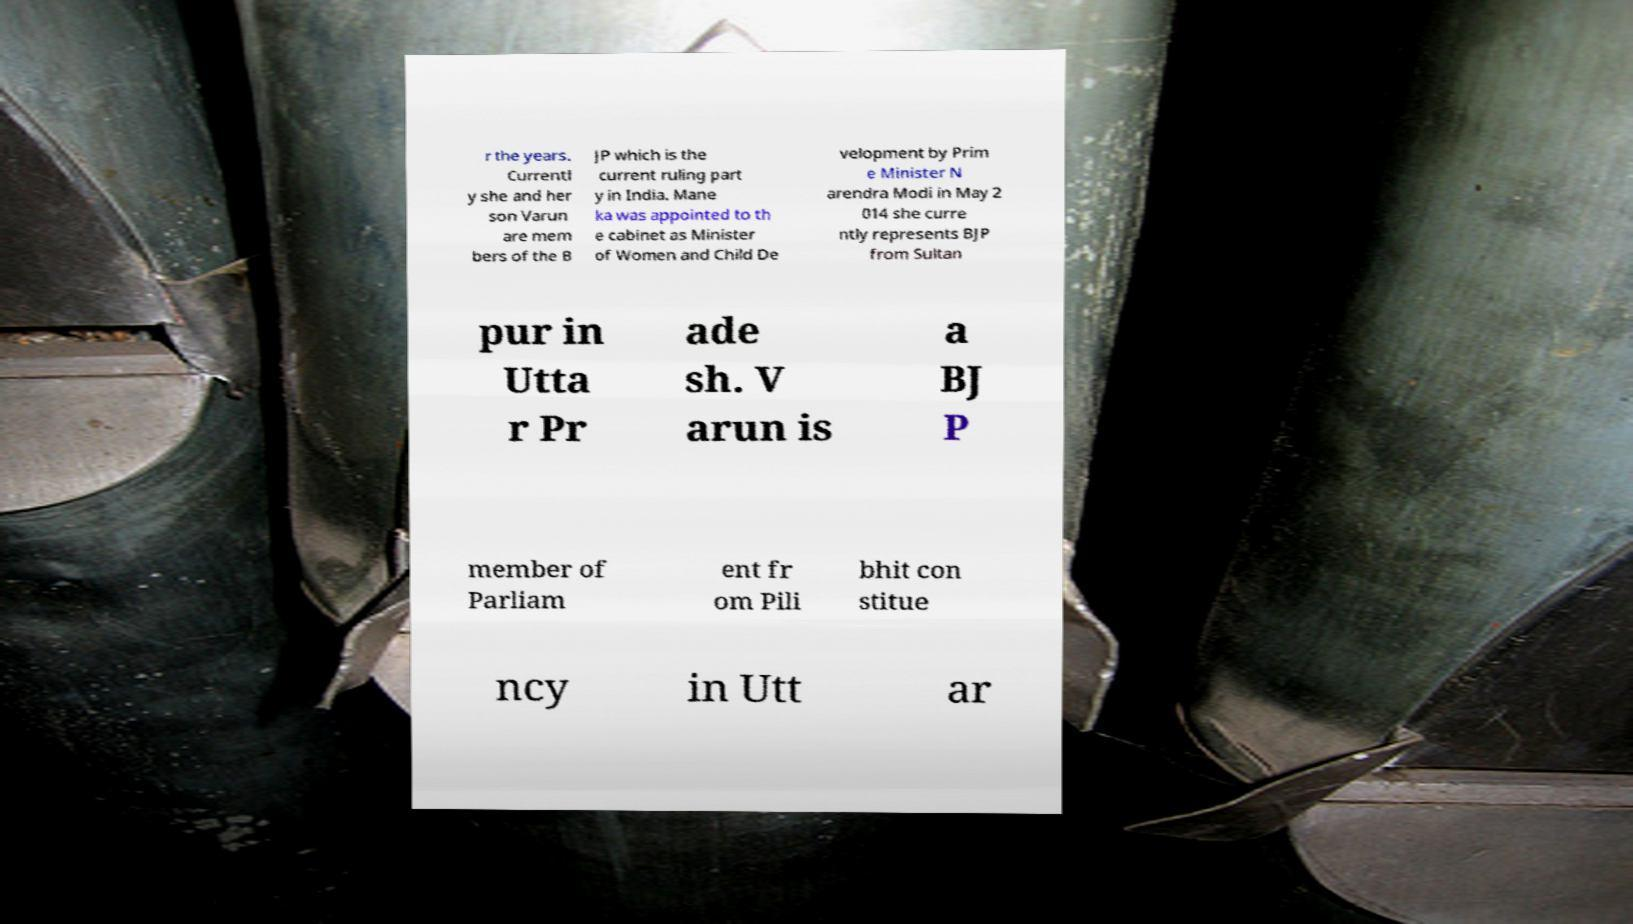There's text embedded in this image that I need extracted. Can you transcribe it verbatim? r the years. Currentl y she and her son Varun are mem bers of the B JP which is the current ruling part y in India. Mane ka was appointed to th e cabinet as Minister of Women and Child De velopment by Prim e Minister N arendra Modi in May 2 014 she curre ntly represents BJP from Sultan pur in Utta r Pr ade sh. V arun is a BJ P member of Parliam ent fr om Pili bhit con stitue ncy in Utt ar 